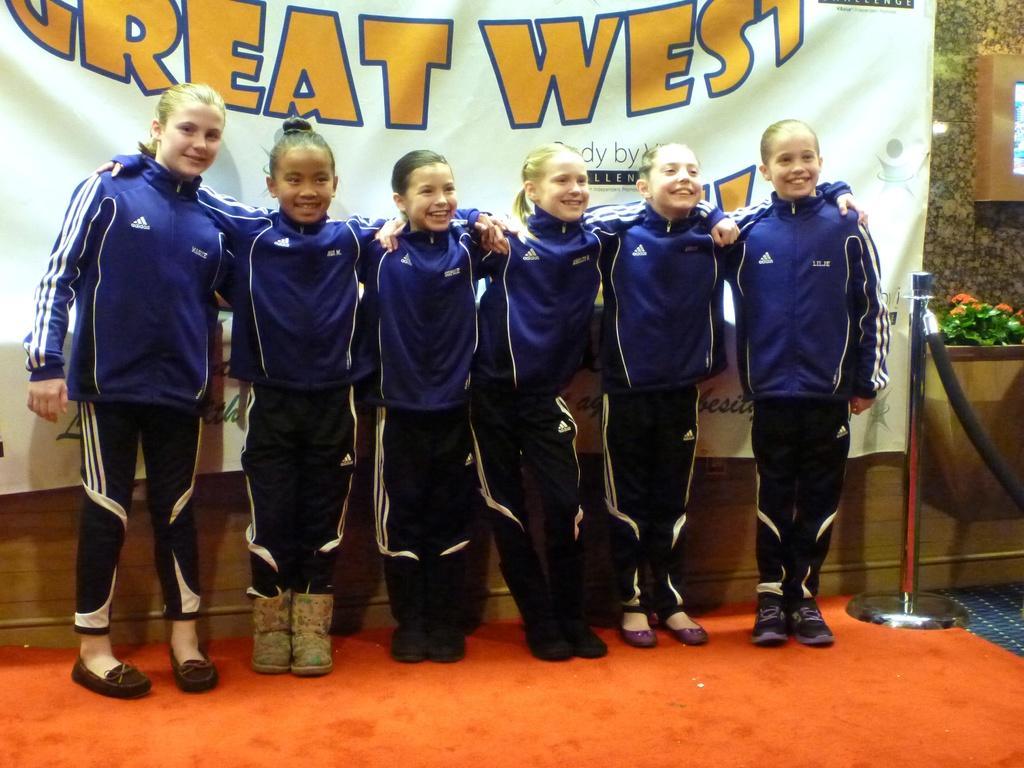Can you describe this image briefly? In this image I can see the orange colored floor, a pole and few children wearing blue, black and white colored dresses are standing. I can see a banner behind them, few plants, flowers and a brown colored object to the wall. 